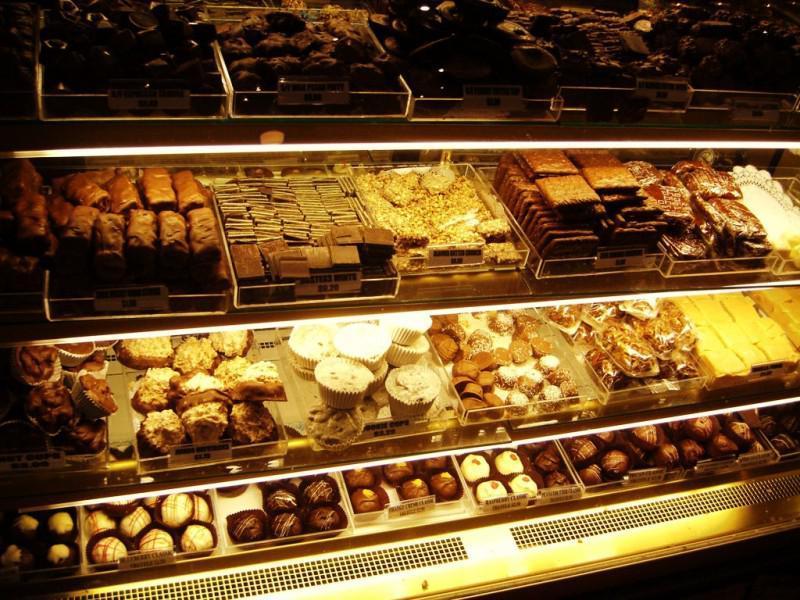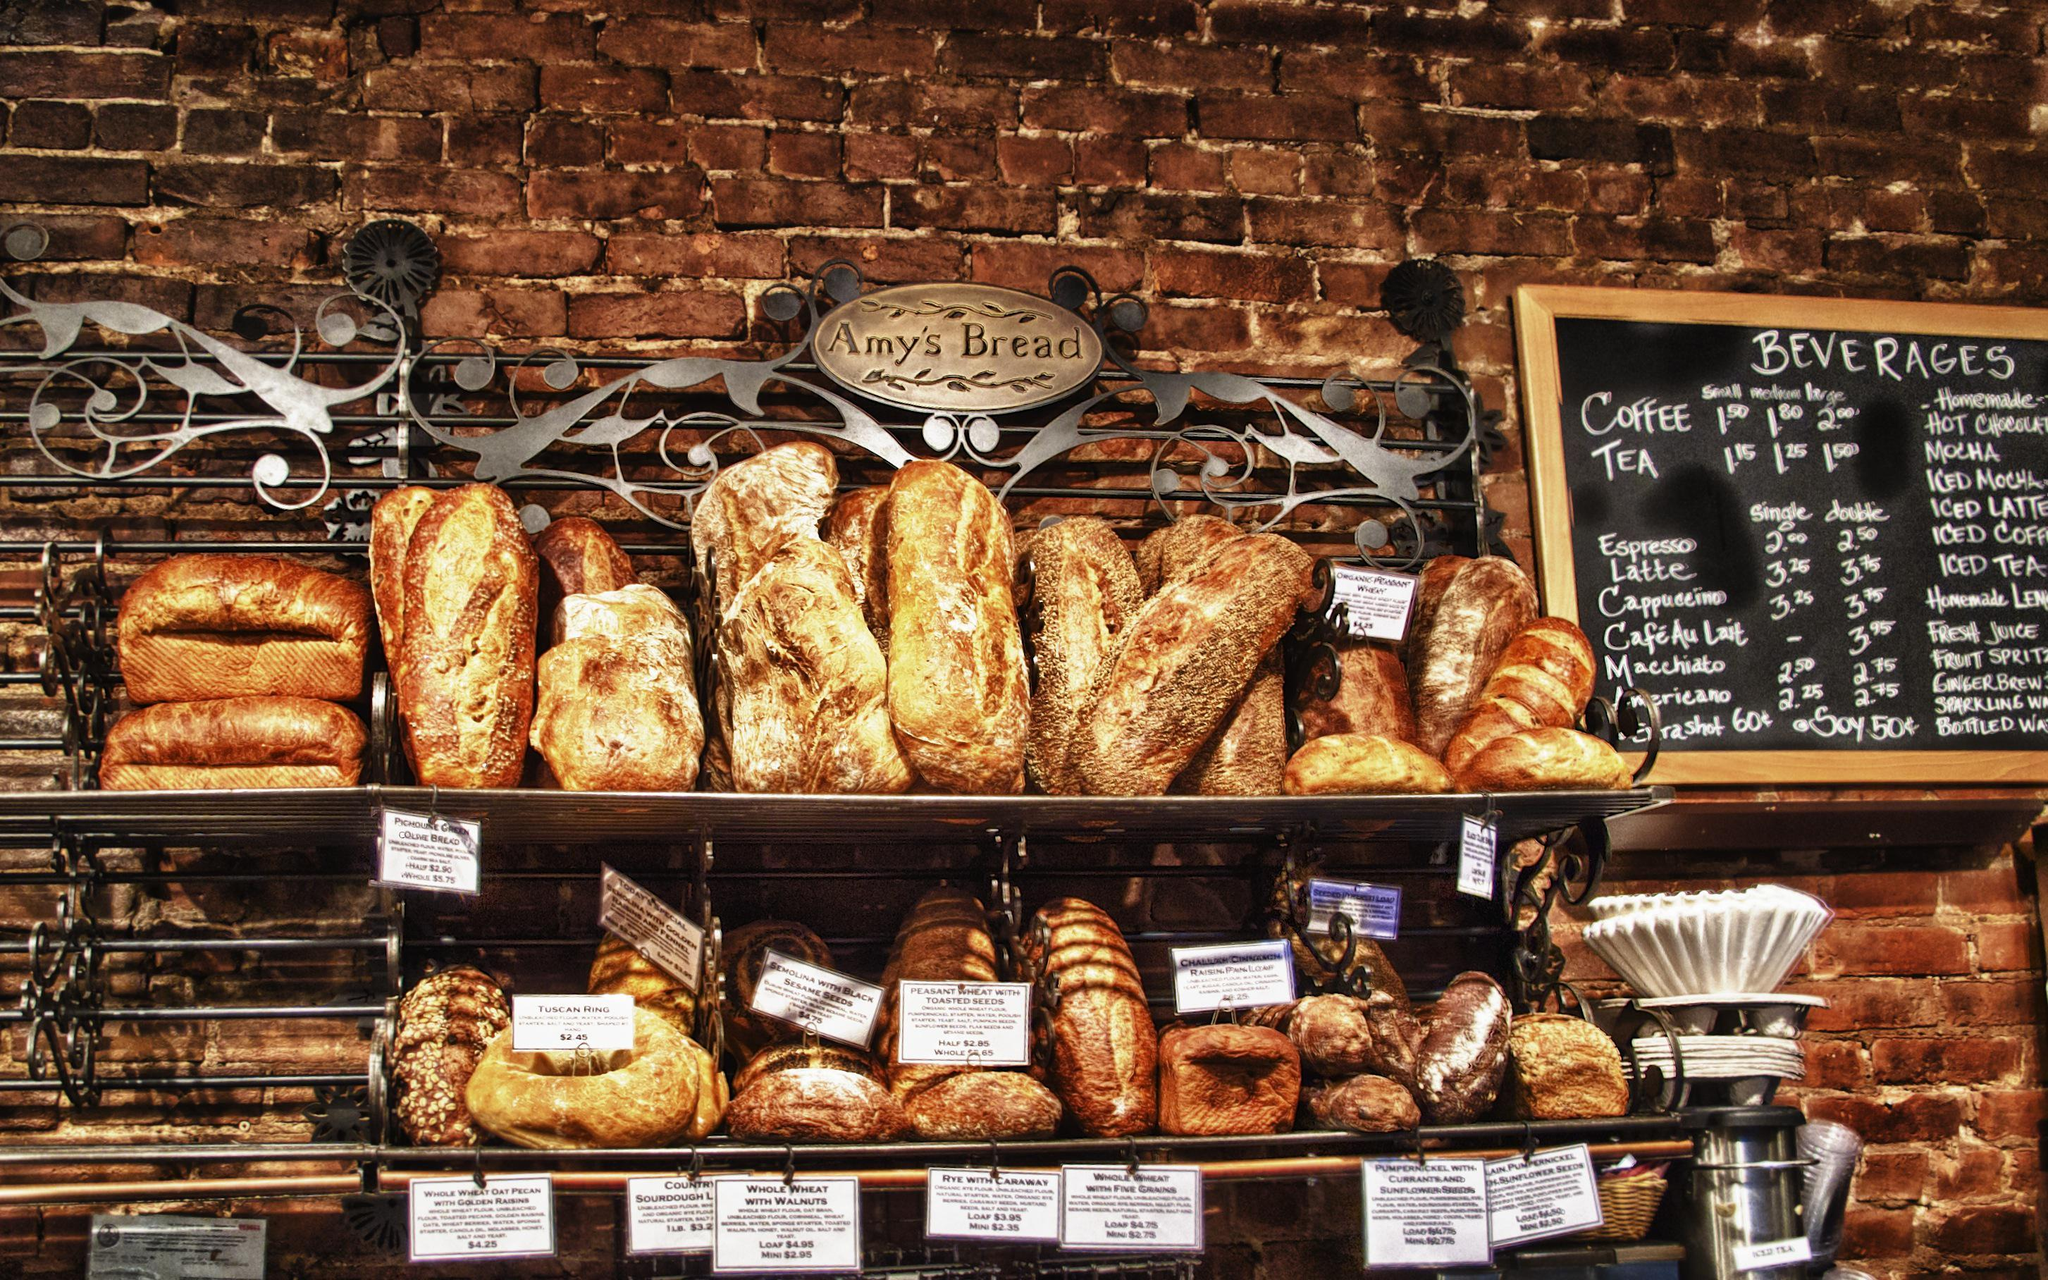The first image is the image on the left, the second image is the image on the right. Assess this claim about the two images: "A black chalkboard advertises items next to a food display in one bakery.". Correct or not? Answer yes or no. Yes. The first image is the image on the left, the second image is the image on the right. Evaluate the accuracy of this statement regarding the images: "Shelves of baked goods are shown up close in both images.". Is it true? Answer yes or no. Yes. 